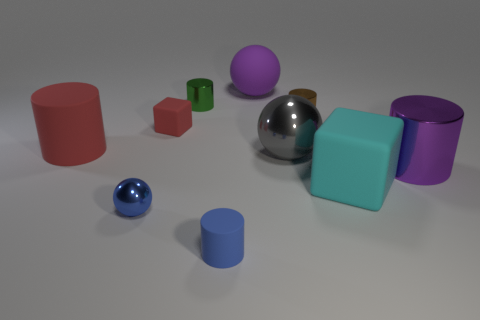What material is the cube that is the same color as the large matte cylinder?
Your response must be concise. Rubber. The rubber cylinder that is the same color as the small sphere is what size?
Your answer should be compact. Small. Is the number of red matte blocks in front of the big purple shiny cylinder less than the number of metal things in front of the gray metal ball?
Your response must be concise. Yes. What color is the big block that is made of the same material as the purple sphere?
Your answer should be very brief. Cyan. There is a big purple object that is the same shape as the blue rubber object; what material is it?
Your answer should be compact. Metal. Is the tiny rubber block the same color as the large rubber cylinder?
Your response must be concise. Yes. Is there a sphere on the left side of the large purple object that is behind the block that is left of the large matte cube?
Give a very brief answer. Yes. The red object that is made of the same material as the large red cylinder is what size?
Your response must be concise. Small. Are there any big rubber things behind the purple shiny object?
Make the answer very short. Yes. There is a block that is behind the big purple metal cylinder; are there any red cylinders that are on the left side of it?
Your answer should be very brief. Yes. 